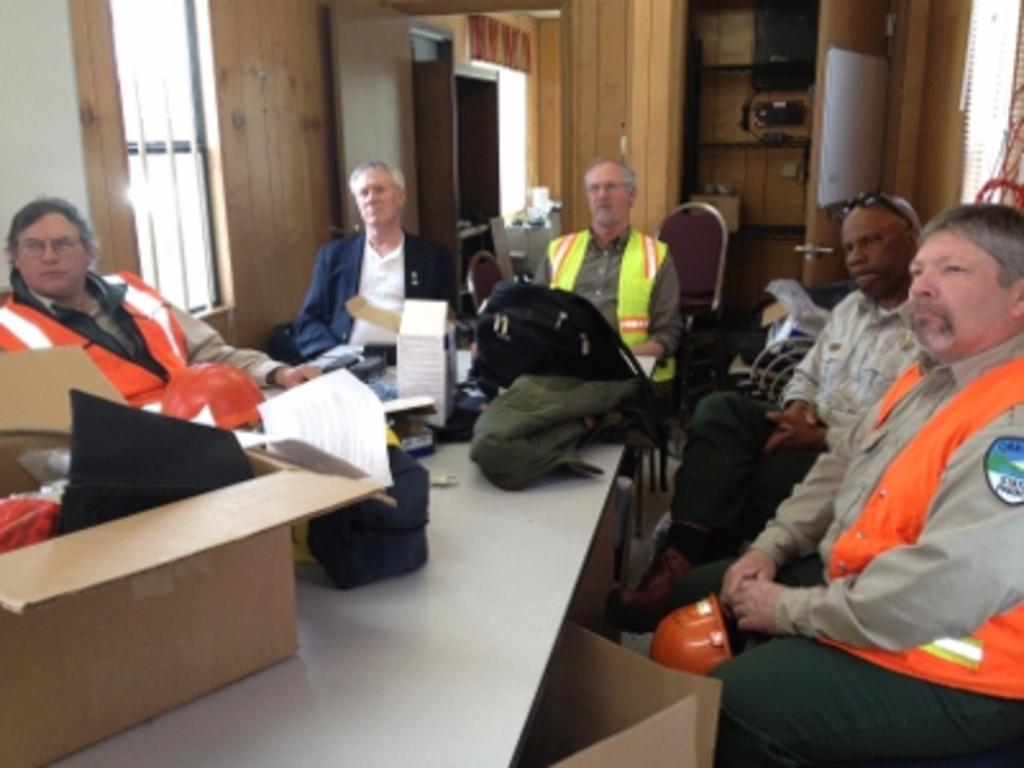Who or what can be seen in the image? There are people in the image. What objects are present in the image? There are bags and papers in the image. What can be seen in the background of the image? There is a wooden wall, a window, and a door in the background of the image. What theory is being discussed by the people in the image? There is no indication in the image that a theory is being discussed; the people are not engaged in any conversation or activity that suggests a discussion of a theory. 